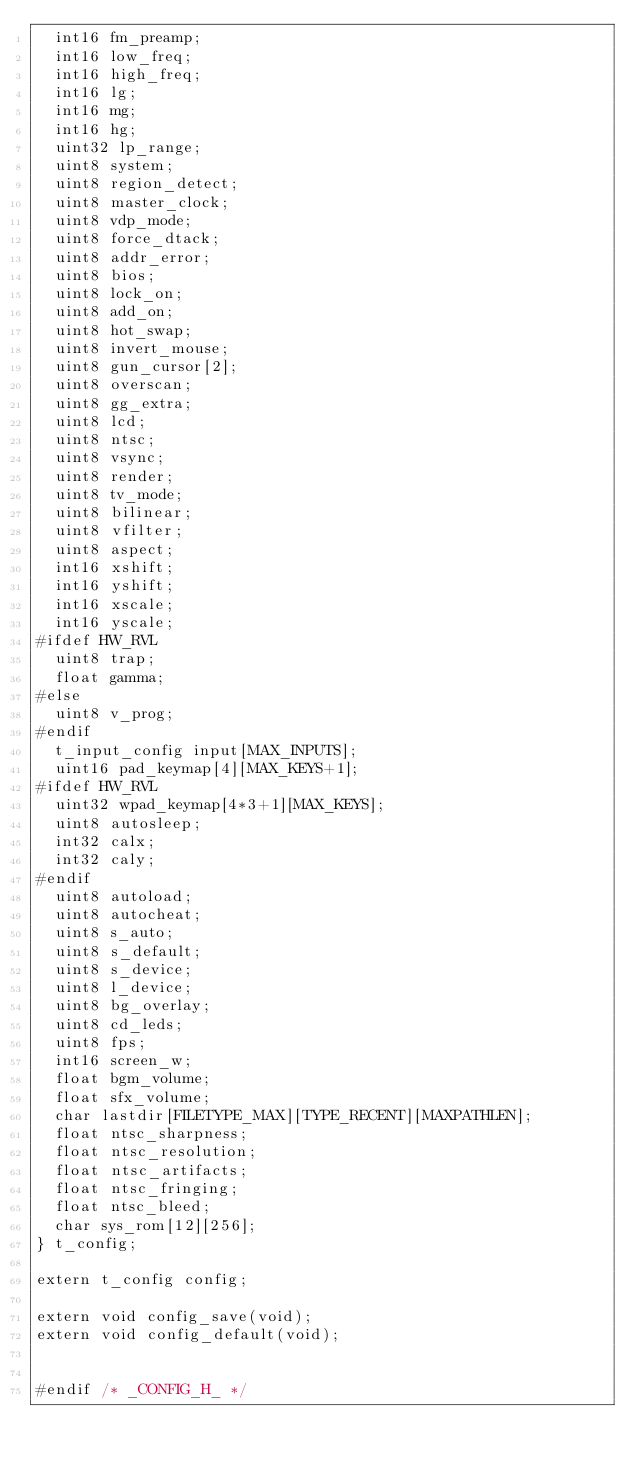<code> <loc_0><loc_0><loc_500><loc_500><_C_>  int16 fm_preamp;
  int16 low_freq;
  int16 high_freq;
  int16 lg;
  int16 mg;
  int16 hg;
  uint32 lp_range;
  uint8 system;
  uint8 region_detect;
  uint8 master_clock;
  uint8 vdp_mode;
  uint8 force_dtack;
  uint8 addr_error;
  uint8 bios;
  uint8 lock_on;
  uint8 add_on;
  uint8 hot_swap;
  uint8 invert_mouse;
  uint8 gun_cursor[2];
  uint8 overscan;
  uint8 gg_extra;
  uint8 lcd;
  uint8 ntsc;
  uint8 vsync;
  uint8 render;
  uint8 tv_mode;
  uint8 bilinear;
  uint8 vfilter;
  uint8 aspect;
  int16 xshift;
  int16 yshift;
  int16 xscale;
  int16 yscale;
#ifdef HW_RVL
  uint8 trap;
  float gamma;
#else
  uint8 v_prog;
#endif
  t_input_config input[MAX_INPUTS];
  uint16 pad_keymap[4][MAX_KEYS+1];
#ifdef HW_RVL
  uint32 wpad_keymap[4*3+1][MAX_KEYS];
  uint8 autosleep;
  int32 calx;
  int32 caly;
#endif
  uint8 autoload;
  uint8 autocheat;
  uint8 s_auto;
  uint8 s_default;
  uint8 s_device;
  uint8 l_device;
  uint8 bg_overlay;
  uint8 cd_leds;
  uint8 fps;
  int16 screen_w;
  float bgm_volume;
  float sfx_volume;
  char lastdir[FILETYPE_MAX][TYPE_RECENT][MAXPATHLEN];
  float ntsc_sharpness;
  float ntsc_resolution;
  float ntsc_artifacts;
  float ntsc_fringing;
  float ntsc_bleed;
  char sys_rom[12][256];
} t_config;

extern t_config config;

extern void config_save(void);
extern void config_default(void);


#endif /* _CONFIG_H_ */

</code> 